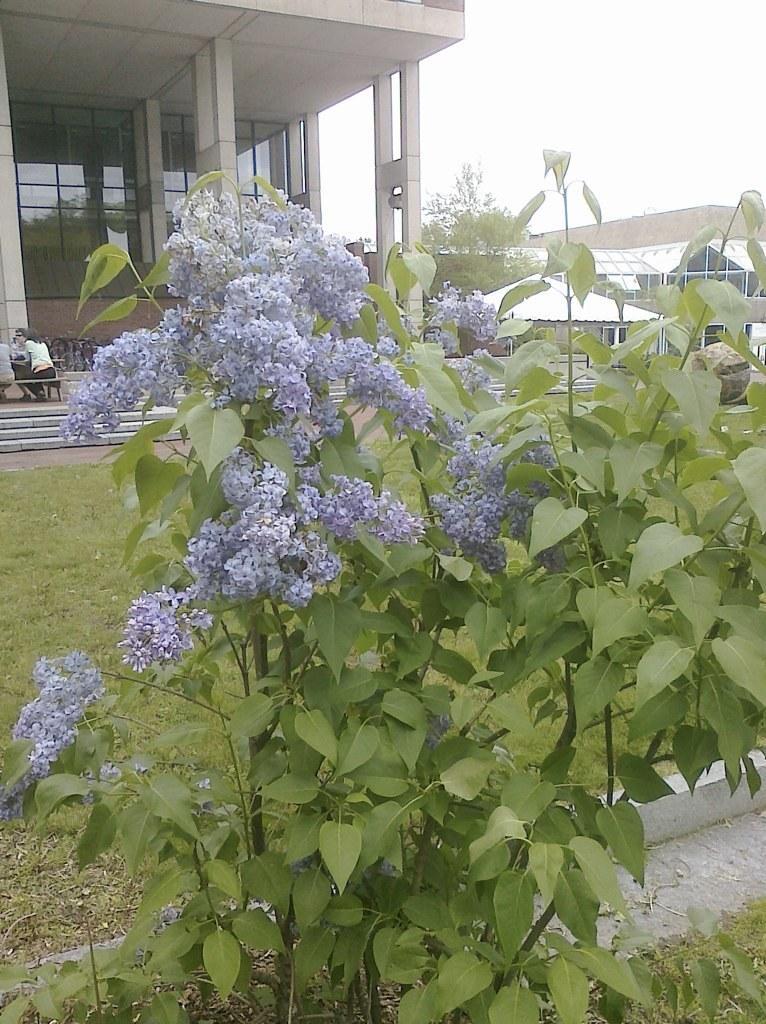How would you summarize this image in a sentence or two? In this image we can see purple color flower plant. Background of the image buildings are there. The land is covered with grass. Left side of the image people are sitting on the bench. 